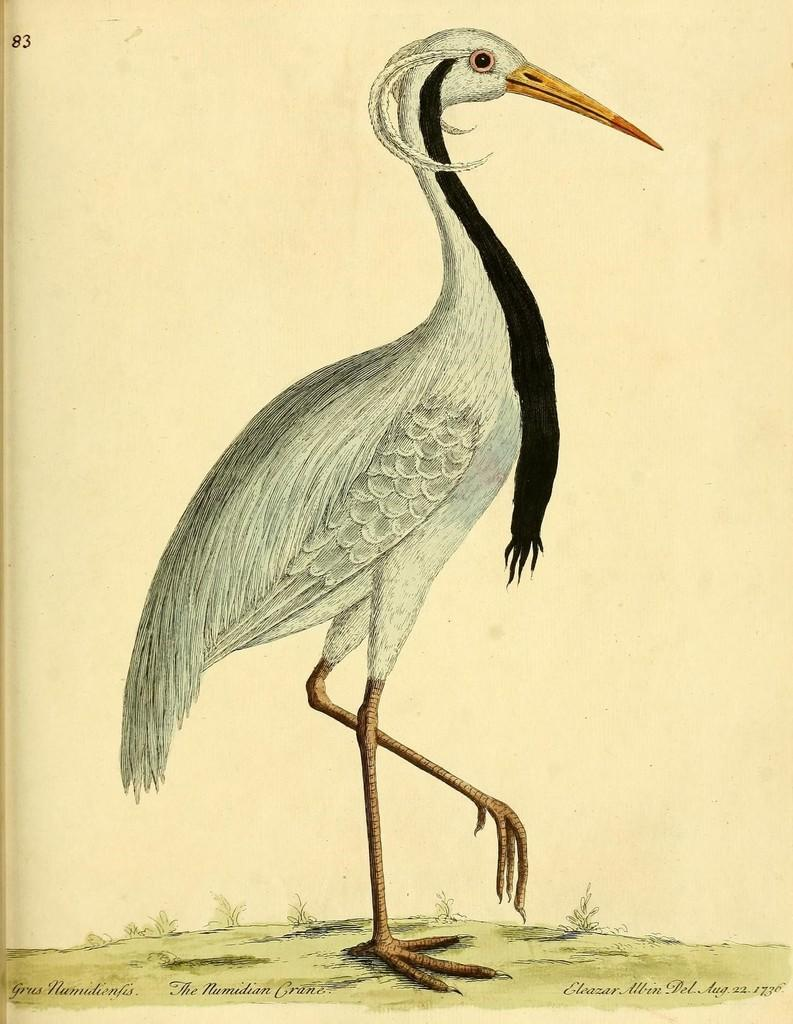What is present on the paper in the image? There is a paper in the image with numbers, words, and an image of a crane. Can you describe the content of the paper in more detail? The paper contains numbers and words, as well as an image of a crane. Reasoning: Let's think step by step by step in order to produce the conversation. We start by identifying the main subject in the image, which is the paper. Then, we expand the conversation to include the specific details about the content of the paper, such as the presence of numbers, words, and an image of a crane. Each question is designed to elicit a specific detail about the image that is known from the provided facts. Absurd Question/Answer: How many matches are on the paper in the image? There are no matches present on the paper in the image. What type of cup is depicted in the image? There is no cup depicted in the image; it only features a paper with numbers, words, and an image of a crane. What type of list is shown on the paper in the image? There is no list present on the paper in the image; it only features numbers, words, and an image of a crane. 